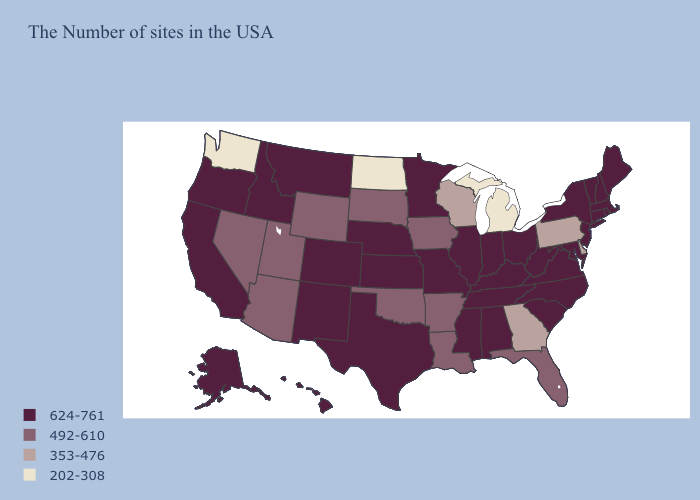Name the states that have a value in the range 624-761?
Short answer required. Maine, Massachusetts, Rhode Island, New Hampshire, Vermont, Connecticut, New York, New Jersey, Maryland, Virginia, North Carolina, South Carolina, West Virginia, Ohio, Kentucky, Indiana, Alabama, Tennessee, Illinois, Mississippi, Missouri, Minnesota, Kansas, Nebraska, Texas, Colorado, New Mexico, Montana, Idaho, California, Oregon, Alaska, Hawaii. Among the states that border South Dakota , which have the highest value?
Concise answer only. Minnesota, Nebraska, Montana. What is the highest value in states that border South Carolina?
Be succinct. 624-761. What is the highest value in the South ?
Be succinct. 624-761. Name the states that have a value in the range 202-308?
Give a very brief answer. Michigan, North Dakota, Washington. What is the value of New Hampshire?
Short answer required. 624-761. Among the states that border Colorado , which have the lowest value?
Be succinct. Oklahoma, Wyoming, Utah, Arizona. What is the lowest value in the MidWest?
Keep it brief. 202-308. Name the states that have a value in the range 492-610?
Answer briefly. Florida, Louisiana, Arkansas, Iowa, Oklahoma, South Dakota, Wyoming, Utah, Arizona, Nevada. Does the map have missing data?
Answer briefly. No. Name the states that have a value in the range 202-308?
Keep it brief. Michigan, North Dakota, Washington. Among the states that border Nevada , does California have the lowest value?
Keep it brief. No. Among the states that border New Mexico , which have the highest value?
Keep it brief. Texas, Colorado. Name the states that have a value in the range 492-610?
Be succinct. Florida, Louisiana, Arkansas, Iowa, Oklahoma, South Dakota, Wyoming, Utah, Arizona, Nevada. Name the states that have a value in the range 624-761?
Give a very brief answer. Maine, Massachusetts, Rhode Island, New Hampshire, Vermont, Connecticut, New York, New Jersey, Maryland, Virginia, North Carolina, South Carolina, West Virginia, Ohio, Kentucky, Indiana, Alabama, Tennessee, Illinois, Mississippi, Missouri, Minnesota, Kansas, Nebraska, Texas, Colorado, New Mexico, Montana, Idaho, California, Oregon, Alaska, Hawaii. 